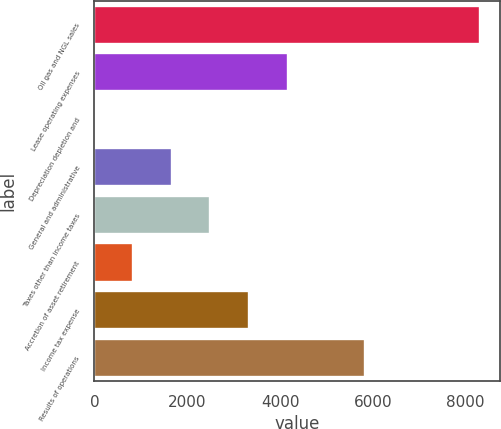<chart> <loc_0><loc_0><loc_500><loc_500><bar_chart><fcel>Oil gas and NGL sales<fcel>Lease operating expenses<fcel>Depreciation depletion and<fcel>General and administrative<fcel>Taxes other than income taxes<fcel>Accretion of asset retirement<fcel>Income tax expense<fcel>Results of operations<nl><fcel>8315<fcel>4161.63<fcel>8.28<fcel>1669.62<fcel>2500.29<fcel>838.95<fcel>3330.96<fcel>5822.97<nl></chart> 